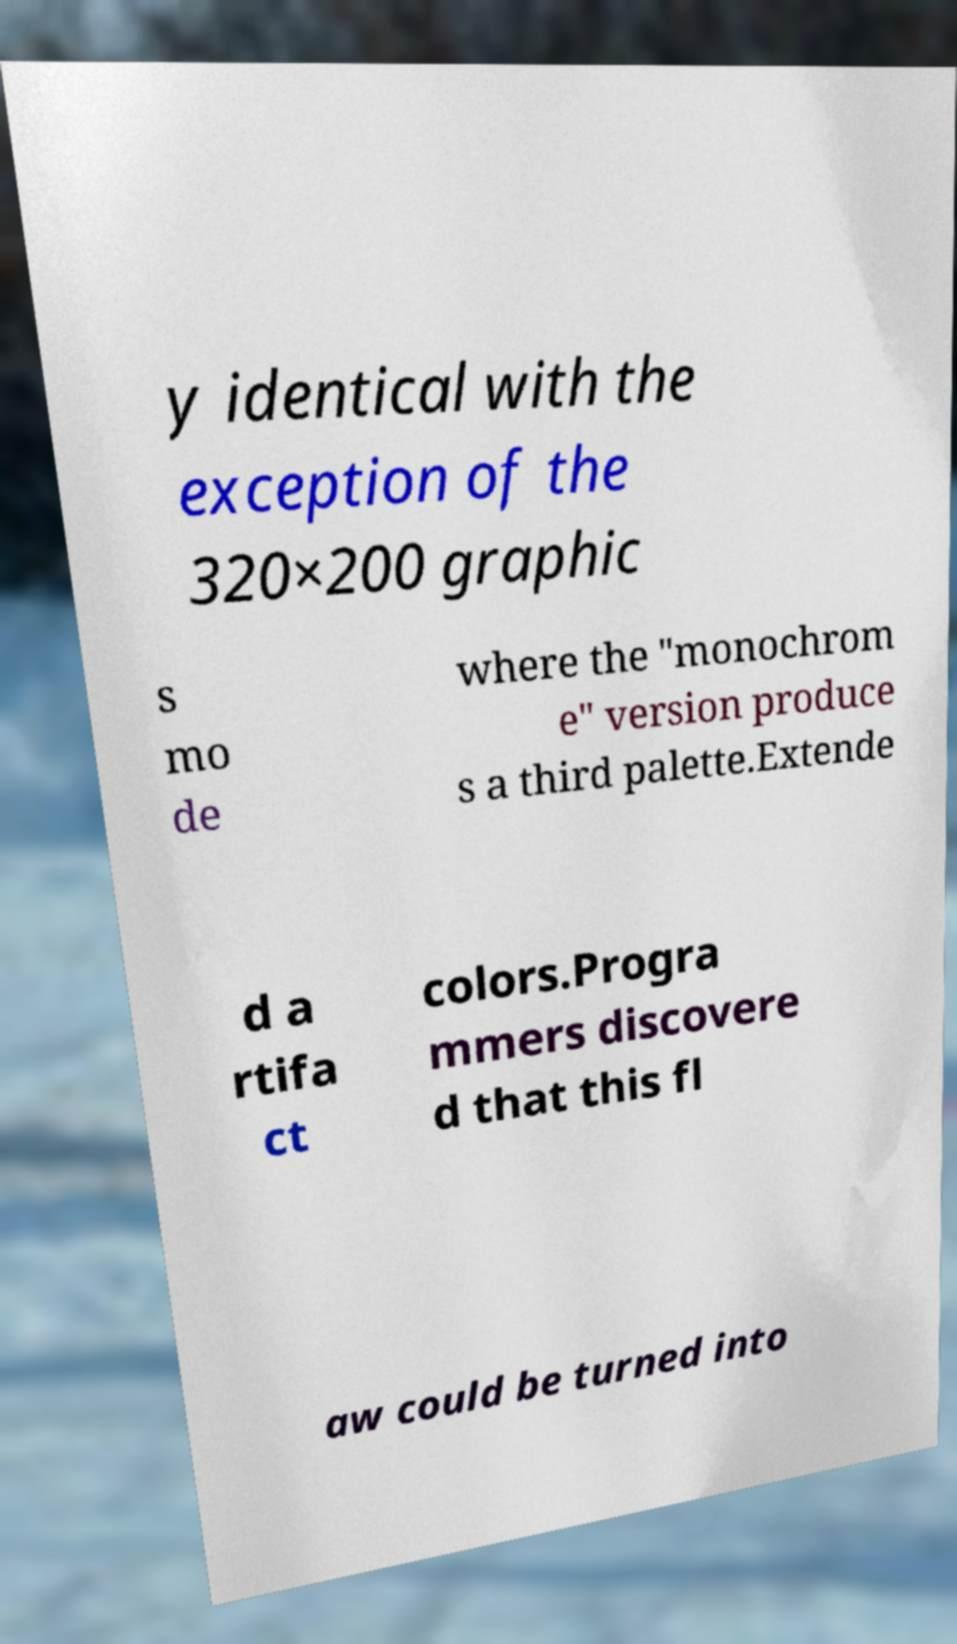For documentation purposes, I need the text within this image transcribed. Could you provide that? y identical with the exception of the 320×200 graphic s mo de where the "monochrom e" version produce s a third palette.Extende d a rtifa ct colors.Progra mmers discovere d that this fl aw could be turned into 